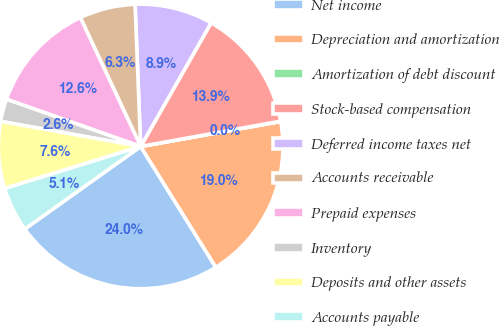Convert chart to OTSL. <chart><loc_0><loc_0><loc_500><loc_500><pie_chart><fcel>Net income<fcel>Depreciation and amortization<fcel>Amortization of debt discount<fcel>Stock-based compensation<fcel>Deferred income taxes net<fcel>Accounts receivable<fcel>Prepaid expenses<fcel>Inventory<fcel>Deposits and other assets<fcel>Accounts payable<nl><fcel>24.0%<fcel>18.95%<fcel>0.04%<fcel>13.91%<fcel>8.87%<fcel>6.34%<fcel>12.65%<fcel>2.56%<fcel>7.6%<fcel>5.08%<nl></chart> 